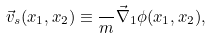Convert formula to latex. <formula><loc_0><loc_0><loc_500><loc_500>\vec { v } _ { s } ( x _ { 1 } , x _ { 2 } ) \equiv \frac { } { m } \vec { \nabla } _ { 1 } \phi ( x _ { 1 } , x _ { 2 } ) ,</formula> 